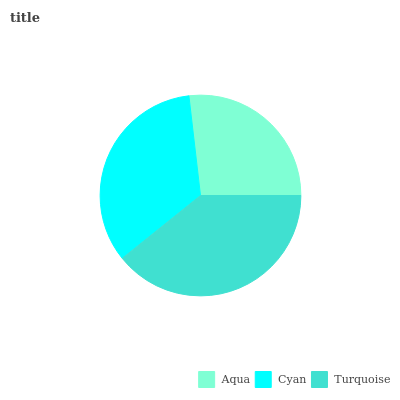Is Aqua the minimum?
Answer yes or no. Yes. Is Turquoise the maximum?
Answer yes or no. Yes. Is Cyan the minimum?
Answer yes or no. No. Is Cyan the maximum?
Answer yes or no. No. Is Cyan greater than Aqua?
Answer yes or no. Yes. Is Aqua less than Cyan?
Answer yes or no. Yes. Is Aqua greater than Cyan?
Answer yes or no. No. Is Cyan less than Aqua?
Answer yes or no. No. Is Cyan the high median?
Answer yes or no. Yes. Is Cyan the low median?
Answer yes or no. Yes. Is Turquoise the high median?
Answer yes or no. No. Is Turquoise the low median?
Answer yes or no. No. 